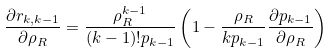Convert formula to latex. <formula><loc_0><loc_0><loc_500><loc_500>\frac { \partial r _ { k , k - 1 } } { \partial \rho _ { R } } = \frac { \rho _ { R } ^ { k - 1 } } { ( k - 1 ) ! p _ { k - 1 } } \left ( 1 - \frac { \rho _ { R } } { k p _ { k - 1 } } \frac { \partial p _ { k - 1 } } { \partial \rho _ { R } } \right )</formula> 